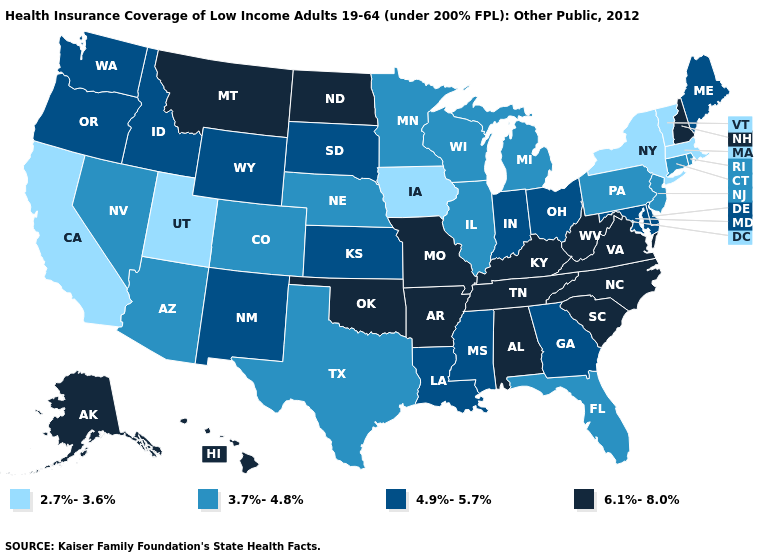Does Tennessee have the highest value in the USA?
Answer briefly. Yes. What is the value of West Virginia?
Short answer required. 6.1%-8.0%. Name the states that have a value in the range 2.7%-3.6%?
Give a very brief answer. California, Iowa, Massachusetts, New York, Utah, Vermont. Among the states that border Vermont , which have the lowest value?
Write a very short answer. Massachusetts, New York. Among the states that border West Virginia , which have the highest value?
Give a very brief answer. Kentucky, Virginia. What is the highest value in the USA?
Be succinct. 6.1%-8.0%. Among the states that border Texas , which have the lowest value?
Keep it brief. Louisiana, New Mexico. Among the states that border Missouri , which have the highest value?
Short answer required. Arkansas, Kentucky, Oklahoma, Tennessee. Does Iowa have the lowest value in the USA?
Short answer required. Yes. What is the lowest value in states that border Maryland?
Be succinct. 3.7%-4.8%. What is the value of Ohio?
Short answer required. 4.9%-5.7%. Does New Hampshire have the lowest value in the USA?
Keep it brief. No. Among the states that border Alabama , does Florida have the lowest value?
Give a very brief answer. Yes. How many symbols are there in the legend?
Quick response, please. 4. 